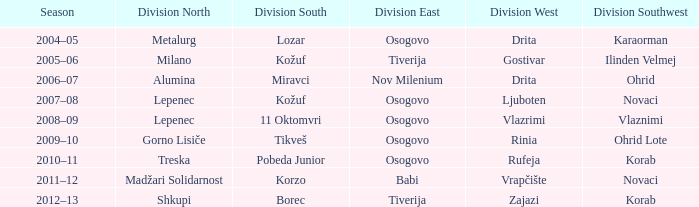Who won Division West when Division North was won by Alumina? Drita. 